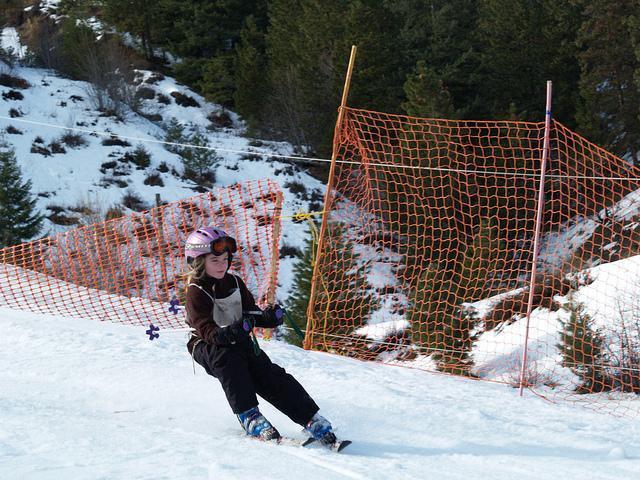How many nets are there?
Give a very brief answer. 2. How many people are visible?
Give a very brief answer. 1. 